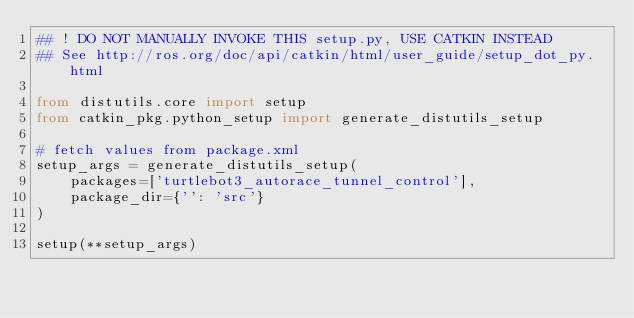Convert code to text. <code><loc_0><loc_0><loc_500><loc_500><_Python_>## ! DO NOT MANUALLY INVOKE THIS setup.py, USE CATKIN INSTEAD
## See http://ros.org/doc/api/catkin/html/user_guide/setup_dot_py.html

from distutils.core import setup
from catkin_pkg.python_setup import generate_distutils_setup

# fetch values from package.xml
setup_args = generate_distutils_setup(
    packages=['turtlebot3_autorace_tunnel_control'],
    package_dir={'': 'src'}
)

setup(**setup_args)
</code> 